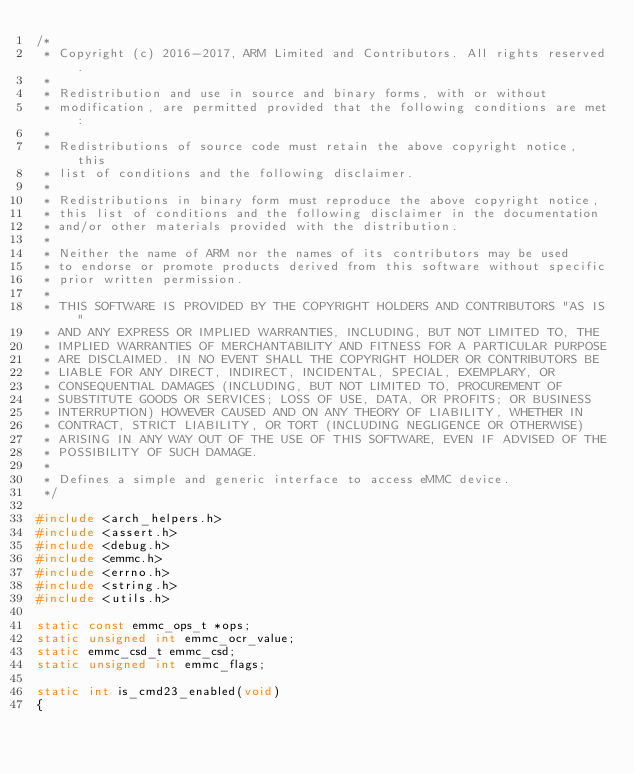Convert code to text. <code><loc_0><loc_0><loc_500><loc_500><_C_>/*
 * Copyright (c) 2016-2017, ARM Limited and Contributors. All rights reserved.
 *
 * Redistribution and use in source and binary forms, with or without
 * modification, are permitted provided that the following conditions are met:
 *
 * Redistributions of source code must retain the above copyright notice, this
 * list of conditions and the following disclaimer.
 *
 * Redistributions in binary form must reproduce the above copyright notice,
 * this list of conditions and the following disclaimer in the documentation
 * and/or other materials provided with the distribution.
 *
 * Neither the name of ARM nor the names of its contributors may be used
 * to endorse or promote products derived from this software without specific
 * prior written permission.
 *
 * THIS SOFTWARE IS PROVIDED BY THE COPYRIGHT HOLDERS AND CONTRIBUTORS "AS IS"
 * AND ANY EXPRESS OR IMPLIED WARRANTIES, INCLUDING, BUT NOT LIMITED TO, THE
 * IMPLIED WARRANTIES OF MERCHANTABILITY AND FITNESS FOR A PARTICULAR PURPOSE
 * ARE DISCLAIMED. IN NO EVENT SHALL THE COPYRIGHT HOLDER OR CONTRIBUTORS BE
 * LIABLE FOR ANY DIRECT, INDIRECT, INCIDENTAL, SPECIAL, EXEMPLARY, OR
 * CONSEQUENTIAL DAMAGES (INCLUDING, BUT NOT LIMITED TO, PROCUREMENT OF
 * SUBSTITUTE GOODS OR SERVICES; LOSS OF USE, DATA, OR PROFITS; OR BUSINESS
 * INTERRUPTION) HOWEVER CAUSED AND ON ANY THEORY OF LIABILITY, WHETHER IN
 * CONTRACT, STRICT LIABILITY, OR TORT (INCLUDING NEGLIGENCE OR OTHERWISE)
 * ARISING IN ANY WAY OUT OF THE USE OF THIS SOFTWARE, EVEN IF ADVISED OF THE
 * POSSIBILITY OF SUCH DAMAGE.
 *
 * Defines a simple and generic interface to access eMMC device.
 */

#include <arch_helpers.h>
#include <assert.h>
#include <debug.h>
#include <emmc.h>
#include <errno.h>
#include <string.h>
#include <utils.h>

static const emmc_ops_t *ops;
static unsigned int emmc_ocr_value;
static emmc_csd_t emmc_csd;
static unsigned int emmc_flags;

static int is_cmd23_enabled(void)
{</code> 